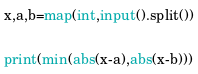<code> <loc_0><loc_0><loc_500><loc_500><_Python_>x,a,b=map(int,input().split())

print(min(abs(x-a),abs(x-b)))</code> 